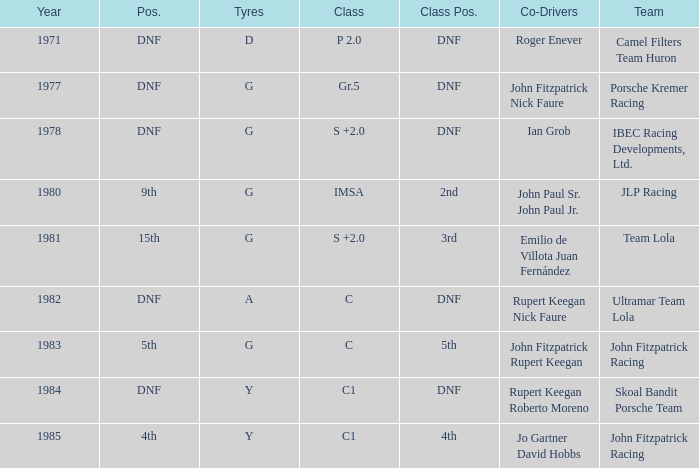What is the earliest year that had a co-driver of Roger Enever? 1971.0. 